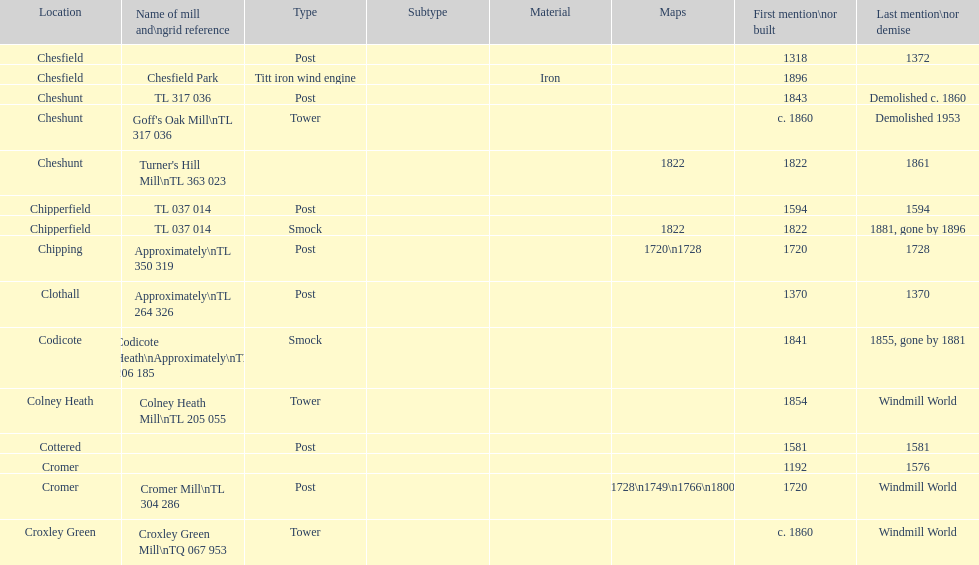What location has the most maps? Cromer. 